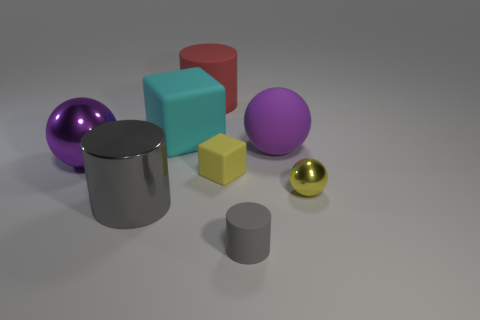Do the red rubber cylinder and the shiny cylinder have the same size?
Offer a very short reply. Yes. Is there a large thing?
Your answer should be compact. Yes. The thing that is the same color as the small cube is what size?
Your response must be concise. Small. There is a yellow thing that is behind the metal ball to the right of the rubber block behind the purple metal thing; what is its size?
Your answer should be compact. Small. What number of purple things are made of the same material as the big cyan object?
Ensure brevity in your answer.  1. What number of purple objects have the same size as the gray matte cylinder?
Provide a short and direct response. 0. What material is the gray thing that is on the right side of the yellow thing to the left of the big purple sphere right of the purple shiny object?
Your response must be concise. Rubber. What number of things are either small metallic spheres or tiny gray rubber cylinders?
Ensure brevity in your answer.  2. The large gray metallic object is what shape?
Offer a terse response. Cylinder. The big purple object that is right of the rubber cylinder that is behind the metal cylinder is what shape?
Make the answer very short. Sphere. 